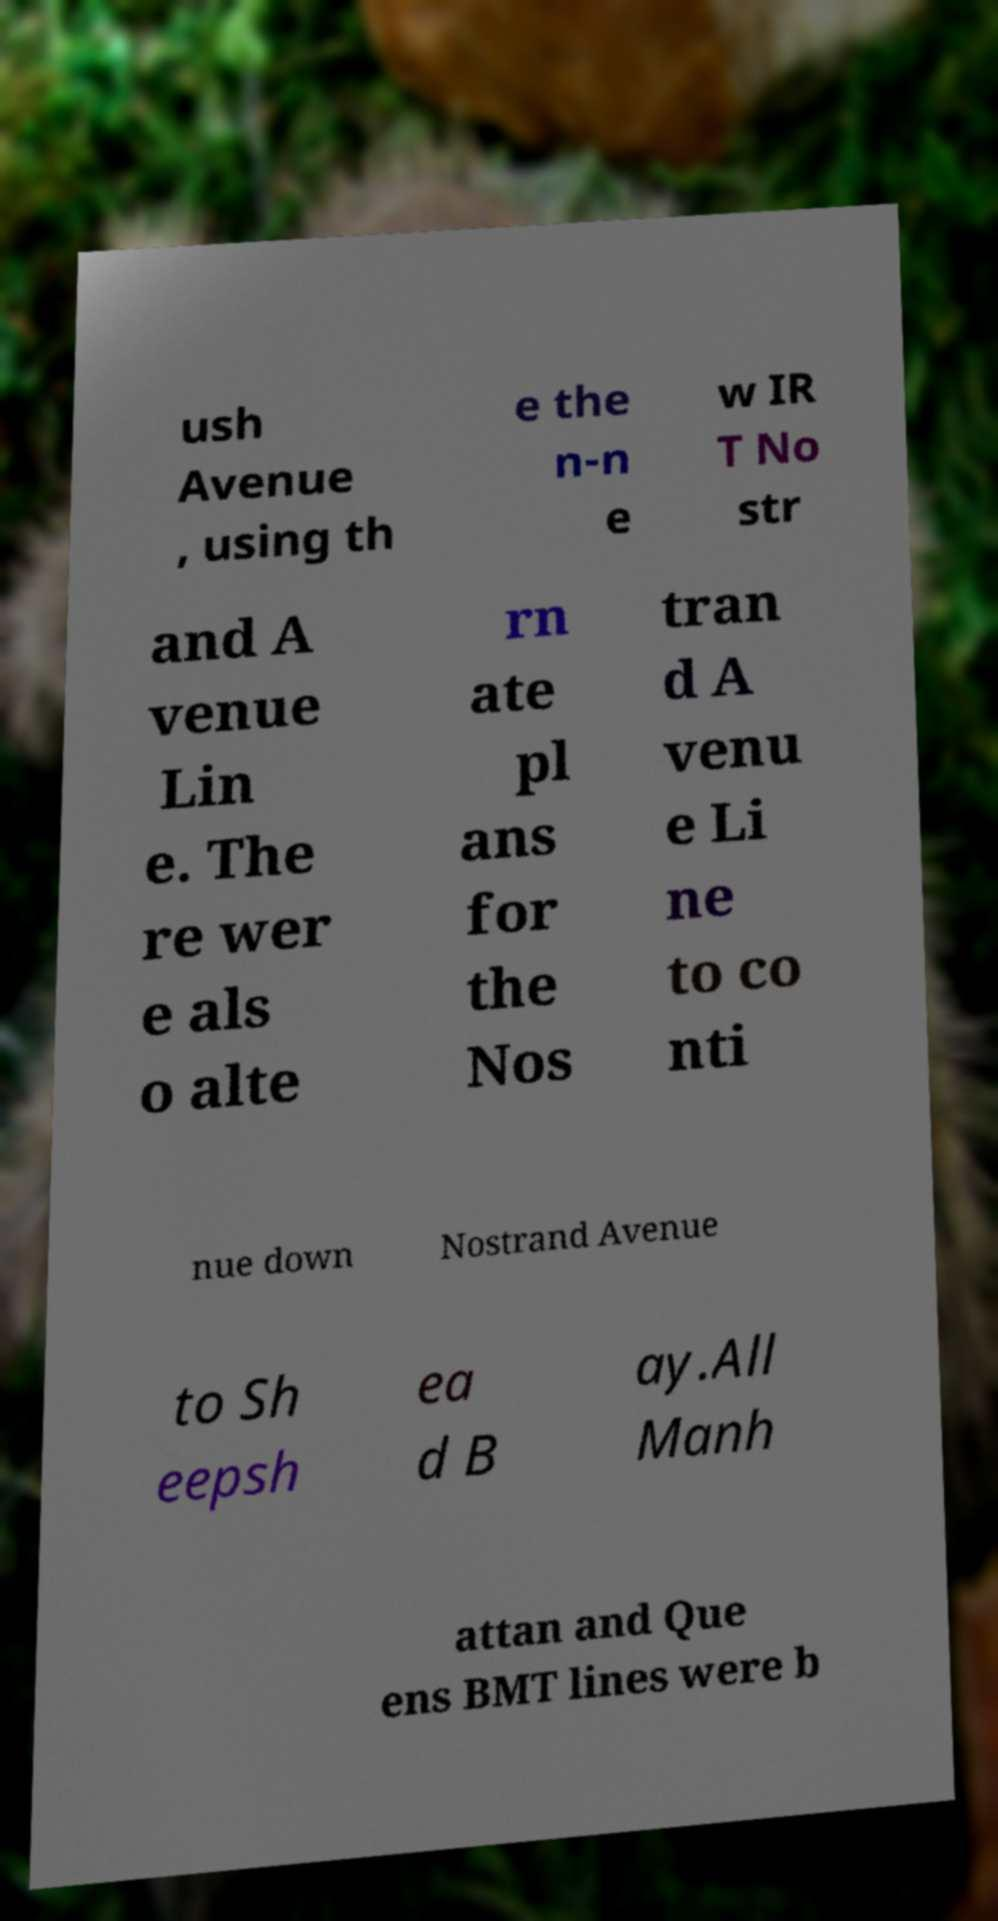Please read and relay the text visible in this image. What does it say? ush Avenue , using th e the n-n e w IR T No str and A venue Lin e. The re wer e als o alte rn ate pl ans for the Nos tran d A venu e Li ne to co nti nue down Nostrand Avenue to Sh eepsh ea d B ay.All Manh attan and Que ens BMT lines were b 